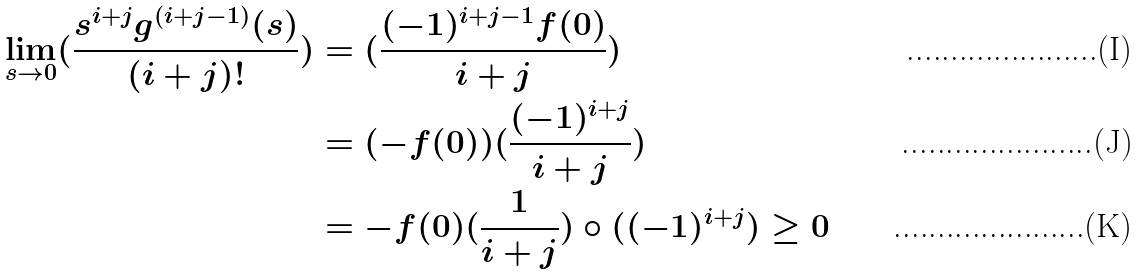Convert formula to latex. <formula><loc_0><loc_0><loc_500><loc_500>\lim _ { s \rightarrow 0 } ( \frac { s ^ { i + j } g ^ { ( i + j - 1 ) } ( s ) } { ( i + j ) ! } ) & = ( \frac { ( - 1 ) ^ { i + j - 1 } f ( 0 ) } { i + j } ) \\ & = ( - f ( 0 ) ) ( \frac { ( - 1 ) ^ { i + j } } { i + j } ) \\ & = - f ( 0 ) ( \frac { 1 } { i + j } ) \circ ( ( - 1 ) ^ { i + j } ) \geq 0</formula> 